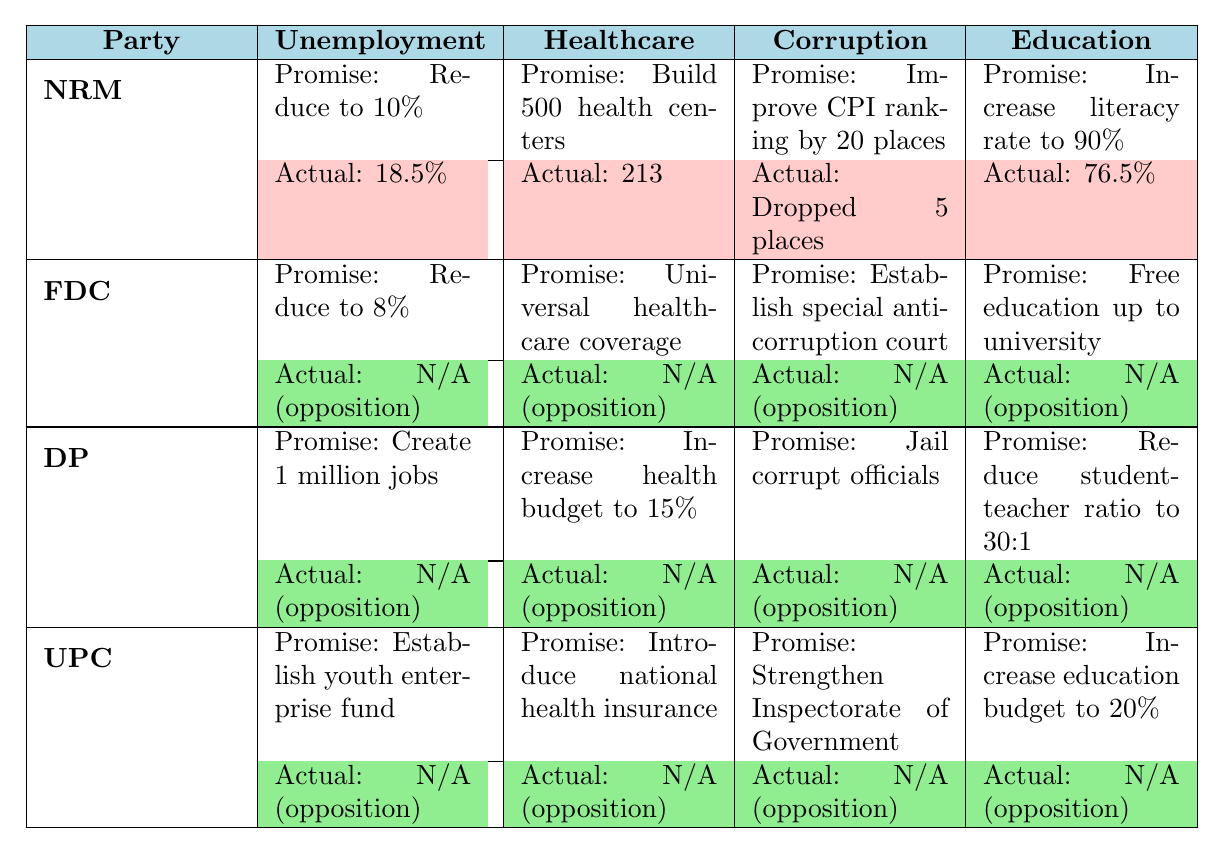What is the promise regarding unemployment for the National Resistance Movement? The table indicates that the promise made by the National Resistance Movement regarding unemployment is to reduce it to 10%.
Answer: Reduce to 10% How many health centers did the National Resistance Movement promise to build? The table shows that the National Resistance Movement promised to build 500 health centers.
Answer: Build 500 health centers What was the actual literacy rate achieved by the National Resistance Movement? According to the table, the actual literacy rate achieved by the National Resistance Movement is 76.5%.
Answer: 76.5% Did any political party make promises about agricultural productivity? Yes, the National Resistance Movement made a promise regarding agricultural productivity, aiming for a 6% annual growth.
Answer: Yes Is the actual achievement for the Forum for Democratic Change regarding healthcare coverage known? No, the table states that the actual achievement for the Forum for Democratic Change regarding healthcare coverage is not available as they are an opposition party.
Answer: No Which party has a promise to reduce unemployment to the lowest percentage? The Forum for Democratic Change has a promise to reduce unemployment to 8%, which is the lowest percentage compared to other parties listed.
Answer: Forum for Democratic Change What is the difference between the NRM's promised and actual unemployment rate? The NRM promised to reduce unemployment to 10% but the actual rate is 18.5%. The difference is 18.5% - 10% = 8.5%.
Answer: 8.5% How many promises have actual achievements reported as "N/A"? The table shows that all promises made by the Forum for Democratic Change, Democratic Party, and Uganda People's Congress have actual achievements reported as "N/A." There are 15 promises total from these parties.
Answer: 15 What percentage did the National Resistance Movement fall in the Corruption Perception Index? The National Resistance Movement promised to improve its CPI ranking by 20 places, but instead, it dropped 5 places, leading to a negative change of 25 places.
Answer: Dropped 5 places If the Democratic Party's promise to create 1 million jobs is successful, what would happen to unemployment levels? If the promise of creating 1 million jobs is successful, it could potentially lower the unemployment rate; however, since the actual achievement data is not available (N/A), the specific impact cannot be determined.
Answer: Unknown impact What can we infer about the performance of the National Resistance Movement based on the table? The National Resistance Movement made several ambitious promises but failed to meet most of them, achieving higher unemployment and lower health center construction than promised.
Answer: Failed to meet most promises 